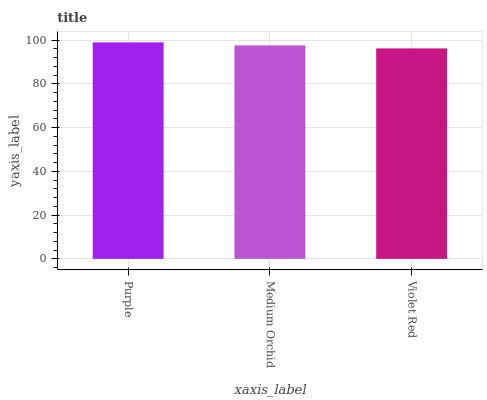Is Violet Red the minimum?
Answer yes or no. Yes. Is Purple the maximum?
Answer yes or no. Yes. Is Medium Orchid the minimum?
Answer yes or no. No. Is Medium Orchid the maximum?
Answer yes or no. No. Is Purple greater than Medium Orchid?
Answer yes or no. Yes. Is Medium Orchid less than Purple?
Answer yes or no. Yes. Is Medium Orchid greater than Purple?
Answer yes or no. No. Is Purple less than Medium Orchid?
Answer yes or no. No. Is Medium Orchid the high median?
Answer yes or no. Yes. Is Medium Orchid the low median?
Answer yes or no. Yes. Is Violet Red the high median?
Answer yes or no. No. Is Violet Red the low median?
Answer yes or no. No. 